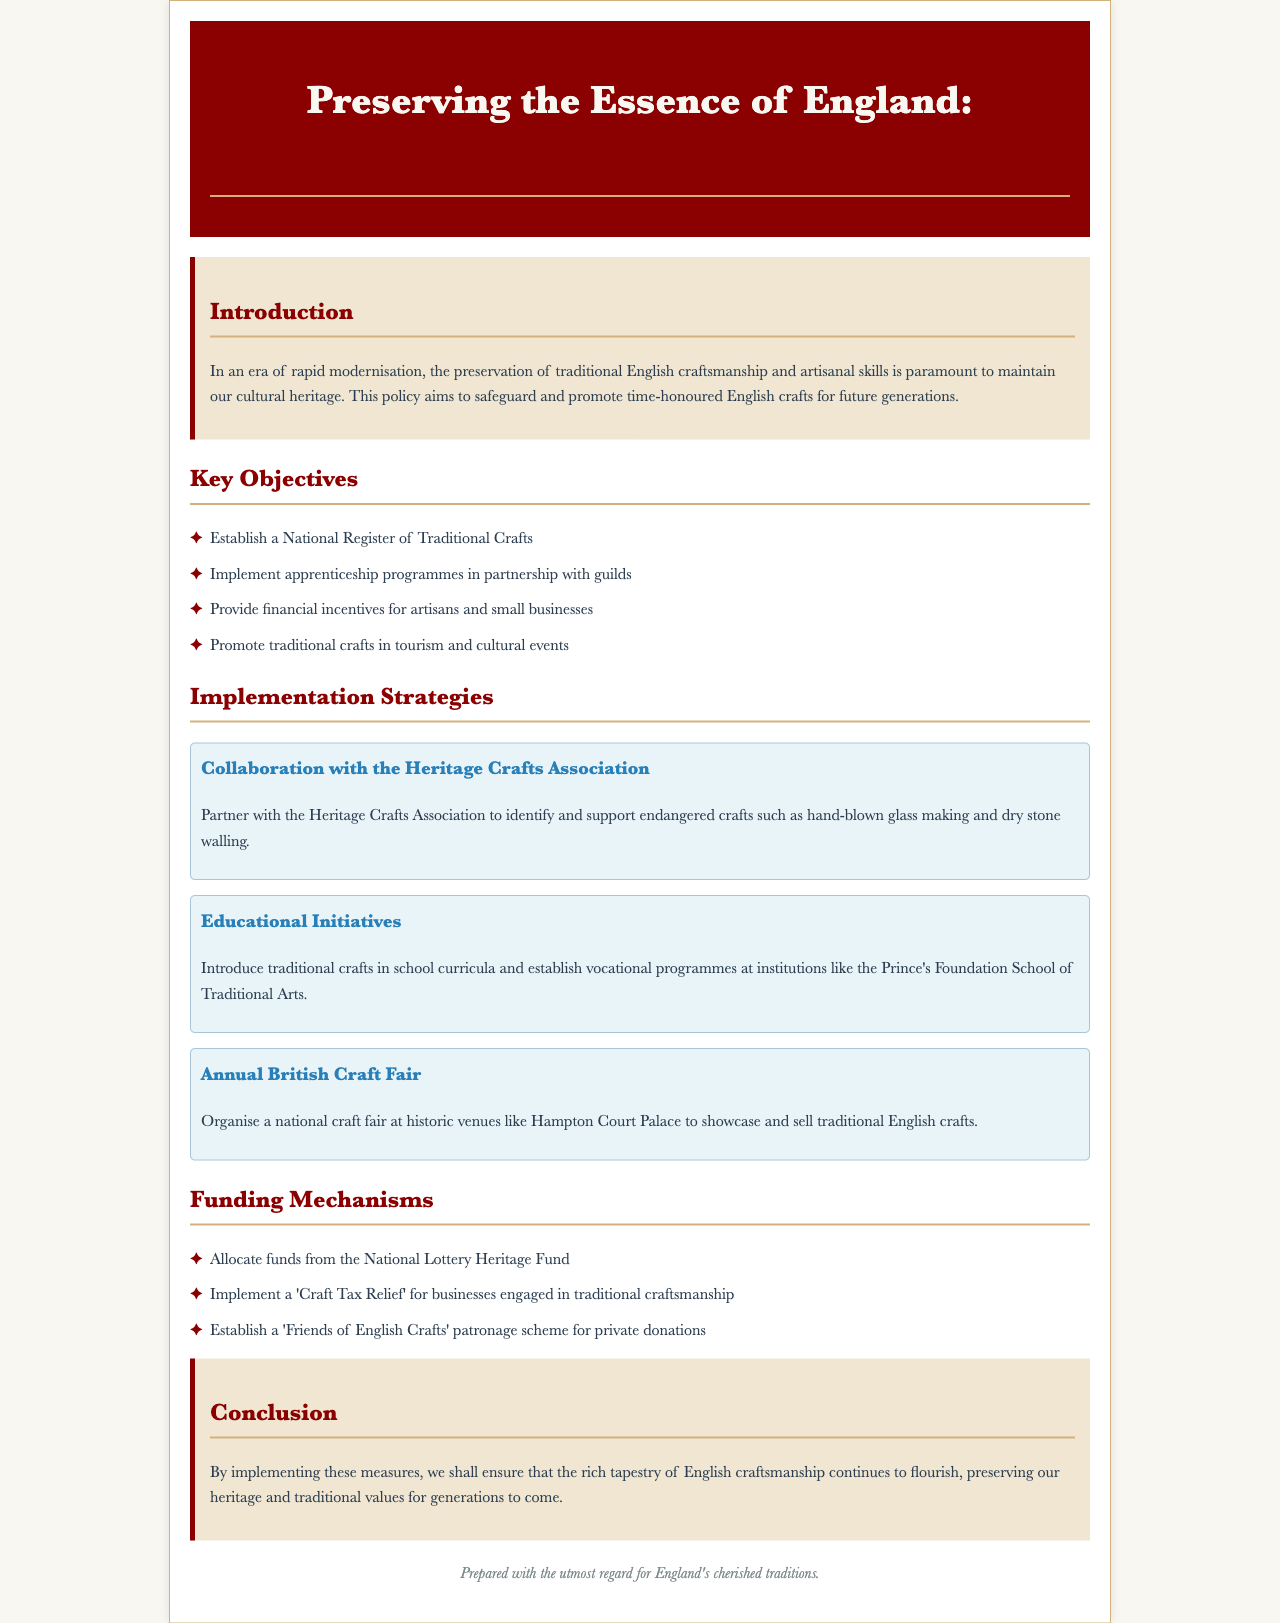What is the title of the policy document? The title of the policy document is clearly stated in the header section, which outlines its purpose and focus on craftsmanship.
Answer: Preserving the Essence of England: A Policy on Traditional Craftsmanship and Artisanal Skills How many key objectives are outlined in the document? The document lists four specific key objectives aimed at preserving traditional craftsmanship.
Answer: Four What is the first strategy for implementation mentioned? The first strategy for implementation focuses on working alongside a notable association to preserve endangered crafts.
Answer: Collaboration with the Heritage Crafts Association What type of event is proposed to showcase traditional crafts? The document outlines an annual event to demonstrate and promote the crafts rooted in English tradition.
Answer: Annual British Craft Fair What funding mechanism involves the National Lottery? The document specifies a funding source that allocates resources to support traditional craftsmanship through the community initiative.
Answer: National Lottery Heritage Fund Which organization will be partnered with for educational initiatives? The educational initiatives in collaboration with schools and vocational programs feature a particular institution that specializes in traditional arts.
Answer: Prince's Foundation School of Traditional Arts What is the main purpose of this policy? The primary objective of this policy is to maintain and promote the cultural heritage associated with artisanal craftsmanship.
Answer: Safeguard and promote time-honoured English crafts What is one incentive provided for artisans and small businesses? The document states a financial incentive specifically designated for smaller-scale craftsmen engaged in traditional practices.
Answer: Financial incentives 